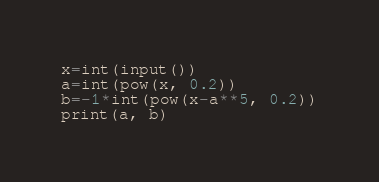Convert code to text. <code><loc_0><loc_0><loc_500><loc_500><_Python_>x=int(input())
a=int(pow(x, 0.2))
b=-1*int(pow(x-a**5, 0.2))
print(a, b)</code> 